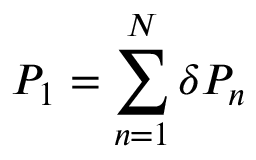<formula> <loc_0><loc_0><loc_500><loc_500>P _ { 1 } = \sum _ { n = 1 } ^ { N } \delta P _ { n }</formula> 